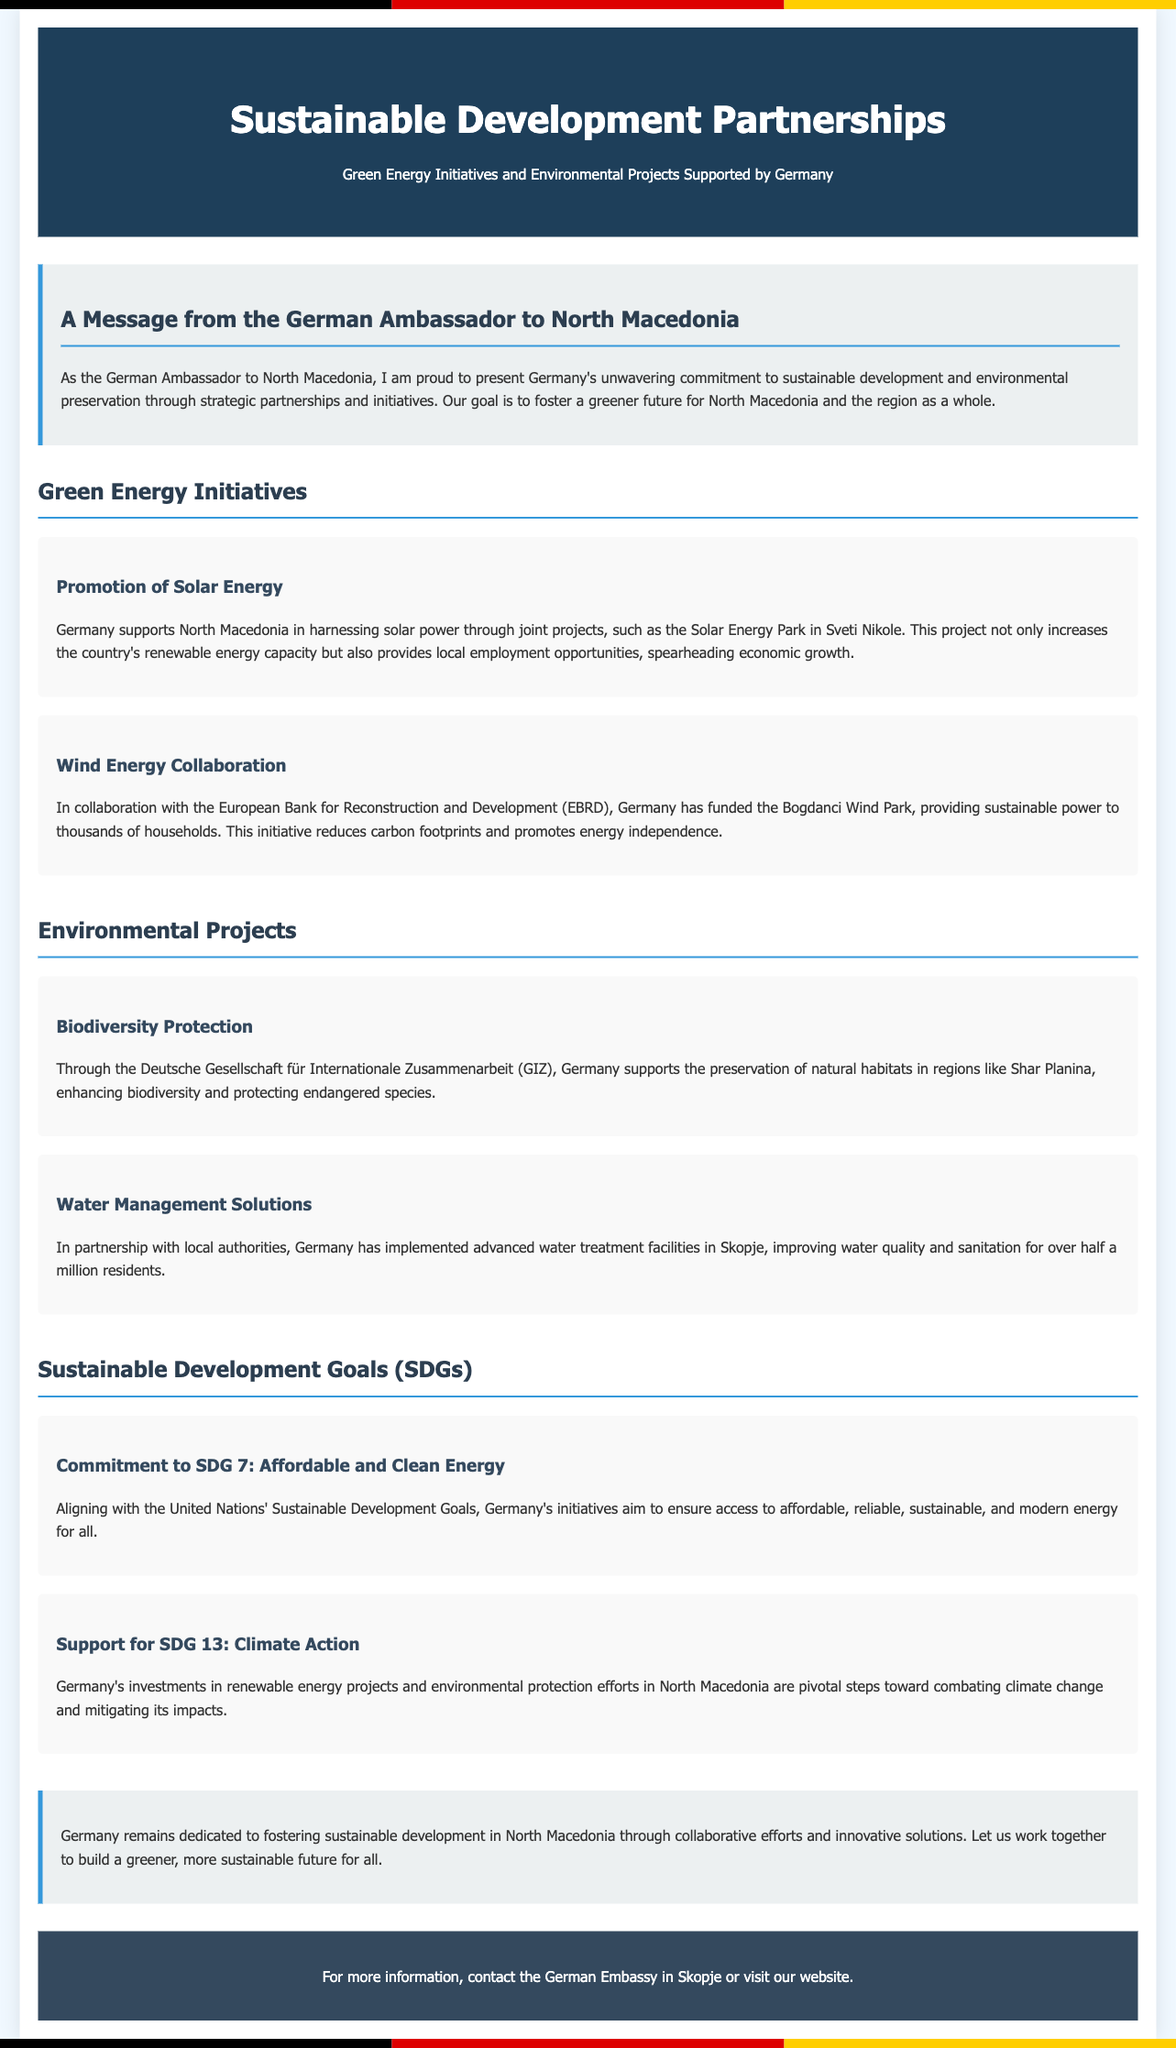What is the title of the document? The title of the document is specified in the header section of the advertisement.
Answer: Sustainable Development Partnerships Who is supporting the Solar Energy Park project? The document states who is supporting the initiative in the content related to Green Energy Initiatives.
Answer: Germany What initiative is being funded in collaboration with EBRD? The document mentions a specific project funded in collaboration with EBRD.
Answer: Bogdanci Wind Park Which biodiversity region is mentioned? The advertisement discusses a specific region related to biodiversity protection.
Answer: Shar Planina How many residents benefit from the water treatment facilities in Skopje? The document provides a specific number related to the water management solutions section.
Answer: over half a million What is Germany's commitment related to SDG 7? The document mentions a specific goal related to affordable and clean energy.
Answer: Affordable and Clean Energy Which organization supports biodiversity preservation? The document identifies an organization involved in biodiversity efforts.
Answer: Deutsche Gesellschaft für Internationale Zusammenarbeit (GIZ) What is the main goal of the document? The advertisement outlines its primary aim at the conclusion, which reflects its objective.
Answer: Foster sustainable development 